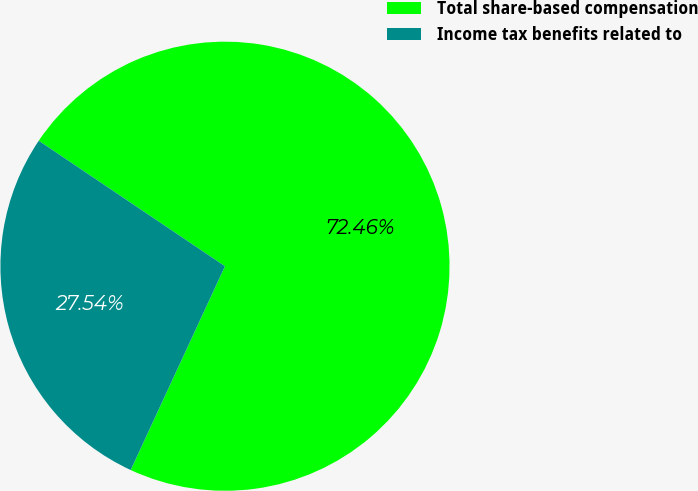<chart> <loc_0><loc_0><loc_500><loc_500><pie_chart><fcel>Total share-based compensation<fcel>Income tax benefits related to<nl><fcel>72.46%<fcel>27.54%<nl></chart> 